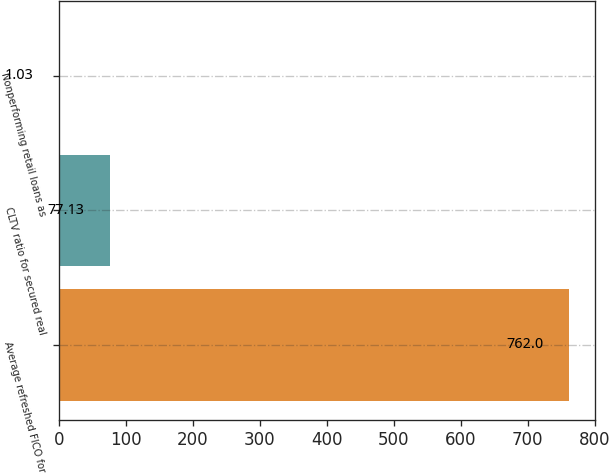Convert chart to OTSL. <chart><loc_0><loc_0><loc_500><loc_500><bar_chart><fcel>Average refreshed FICO for<fcel>CLTV ratio for secured real<fcel>Nonperforming retail loans as<nl><fcel>762<fcel>77.13<fcel>1.03<nl></chart> 